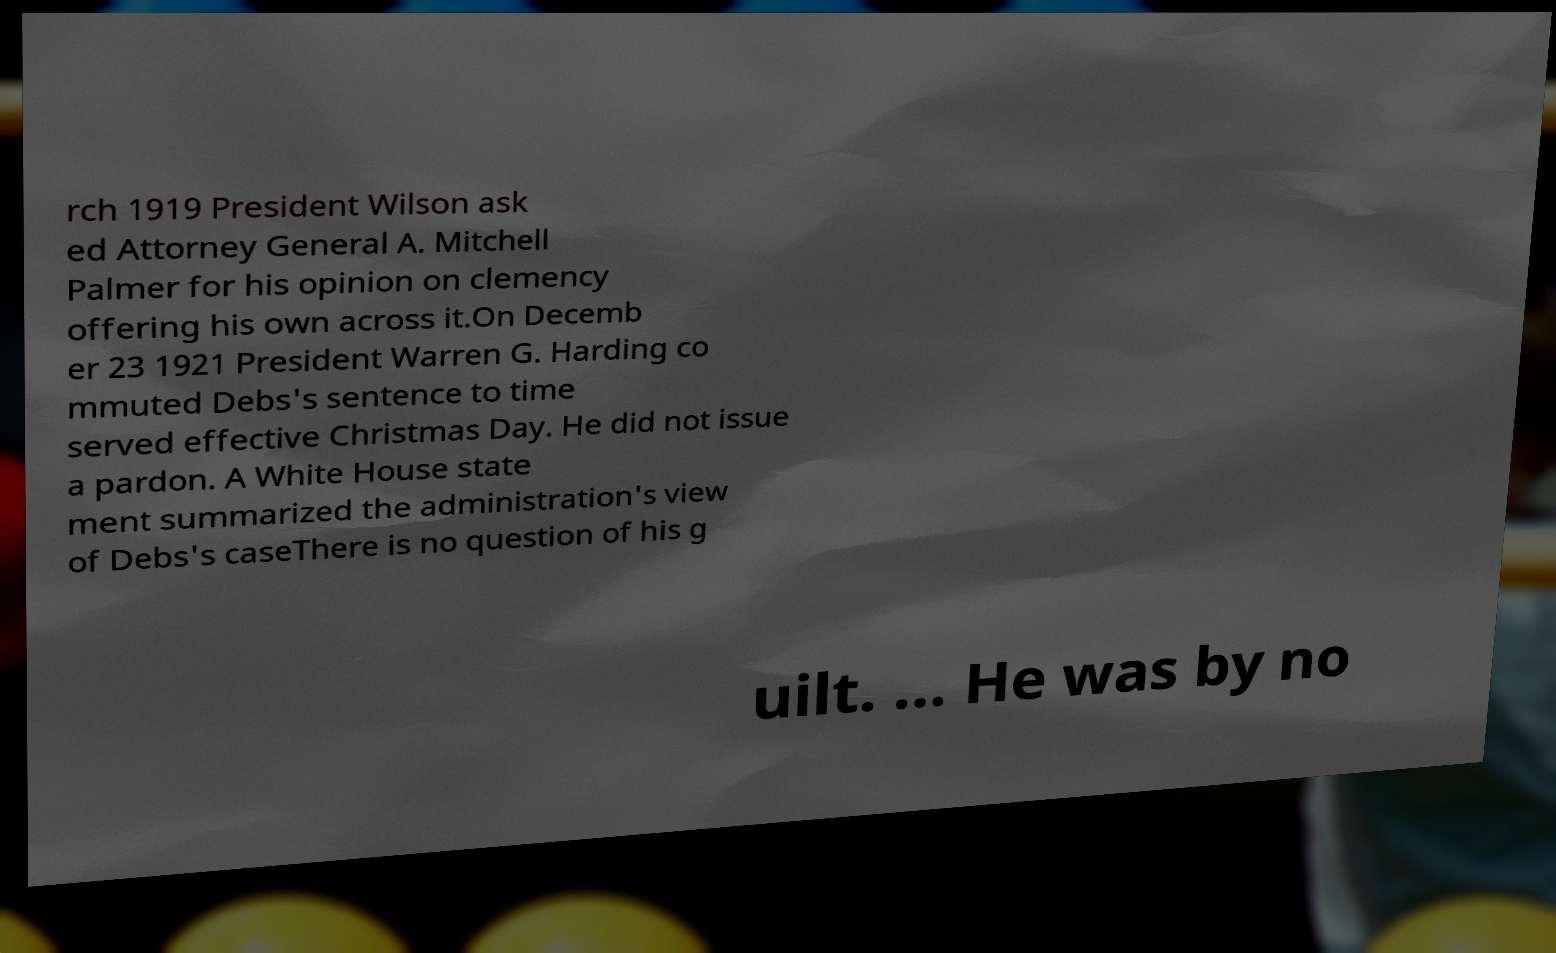Could you assist in decoding the text presented in this image and type it out clearly? rch 1919 President Wilson ask ed Attorney General A. Mitchell Palmer for his opinion on clemency offering his own across it.On Decemb er 23 1921 President Warren G. Harding co mmuted Debs's sentence to time served effective Christmas Day. He did not issue a pardon. A White House state ment summarized the administration's view of Debs's caseThere is no question of his g uilt. ... He was by no 